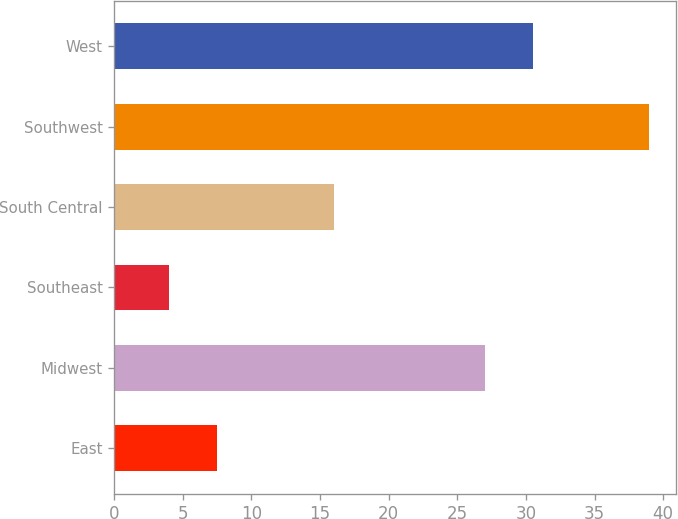<chart> <loc_0><loc_0><loc_500><loc_500><bar_chart><fcel>East<fcel>Midwest<fcel>Southeast<fcel>South Central<fcel>Southwest<fcel>West<nl><fcel>7.5<fcel>27<fcel>4<fcel>16<fcel>39<fcel>30.5<nl></chart> 